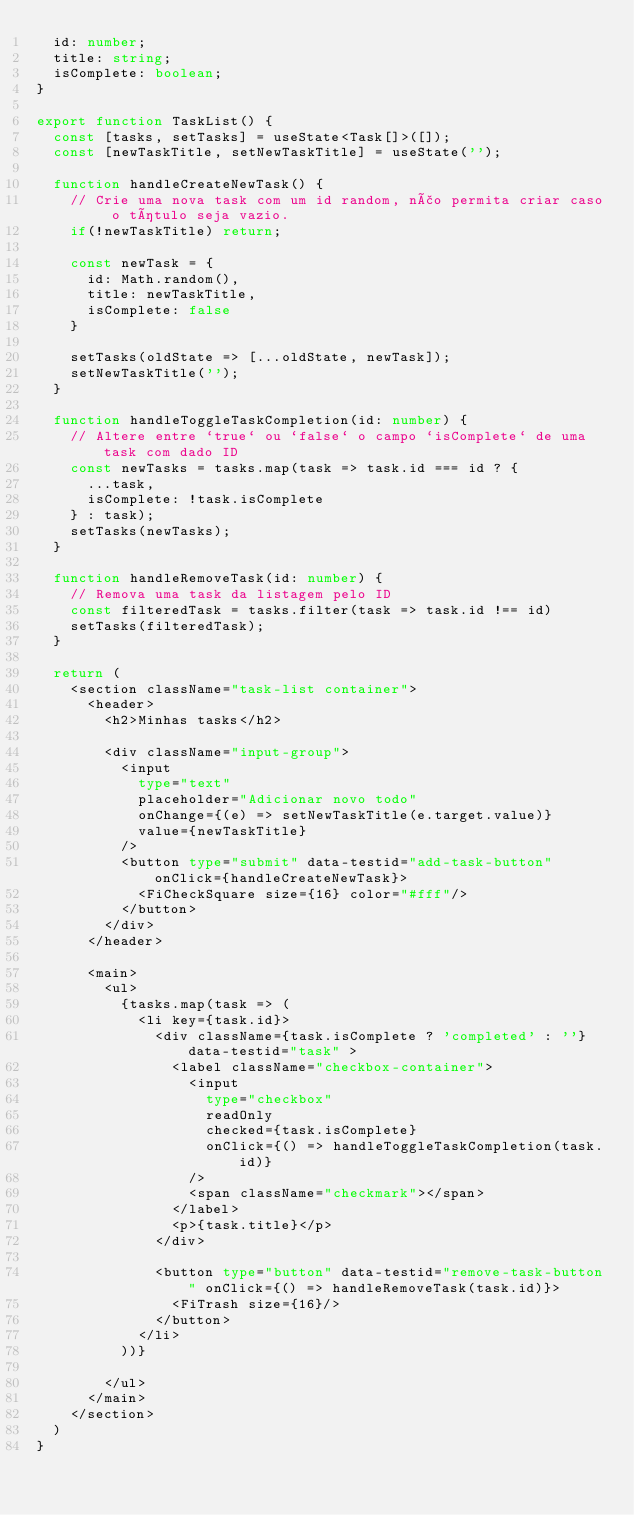<code> <loc_0><loc_0><loc_500><loc_500><_TypeScript_>  id: number;
  title: string;
  isComplete: boolean;
}

export function TaskList() {
  const [tasks, setTasks] = useState<Task[]>([]);
  const [newTaskTitle, setNewTaskTitle] = useState('');

  function handleCreateNewTask() {
    // Crie uma nova task com um id random, não permita criar caso o título seja vazio.
    if(!newTaskTitle) return;

    const newTask = {
      id: Math.random(),
      title: newTaskTitle,
      isComplete: false
    }

    setTasks(oldState => [...oldState, newTask]);
    setNewTaskTitle('');
  }

  function handleToggleTaskCompletion(id: number) {
    // Altere entre `true` ou `false` o campo `isComplete` de uma task com dado ID
    const newTasks = tasks.map(task => task.id === id ? {
      ...task,
      isComplete: !task.isComplete
    } : task);
    setTasks(newTasks);
  }

  function handleRemoveTask(id: number) {
    // Remova uma task da listagem pelo ID
    const filteredTask = tasks.filter(task => task.id !== id)
    setTasks(filteredTask);
  }

  return (
    <section className="task-list container">
      <header>
        <h2>Minhas tasks</h2>

        <div className="input-group">
          <input 
            type="text" 
            placeholder="Adicionar novo todo" 
            onChange={(e) => setNewTaskTitle(e.target.value)}
            value={newTaskTitle}
          />
          <button type="submit" data-testid="add-task-button" onClick={handleCreateNewTask}>
            <FiCheckSquare size={16} color="#fff"/>
          </button>
        </div>
      </header>

      <main>
        <ul>
          {tasks.map(task => (
            <li key={task.id}>
              <div className={task.isComplete ? 'completed' : ''} data-testid="task" >
                <label className="checkbox-container">
                  <input 
                    type="checkbox"
                    readOnly
                    checked={task.isComplete}
                    onClick={() => handleToggleTaskCompletion(task.id)}
                  />
                  <span className="checkmark"></span>
                </label>
                <p>{task.title}</p>
              </div>

              <button type="button" data-testid="remove-task-button" onClick={() => handleRemoveTask(task.id)}>
                <FiTrash size={16}/>
              </button>
            </li>
          ))}
          
        </ul>
      </main>
    </section>
  )
}</code> 